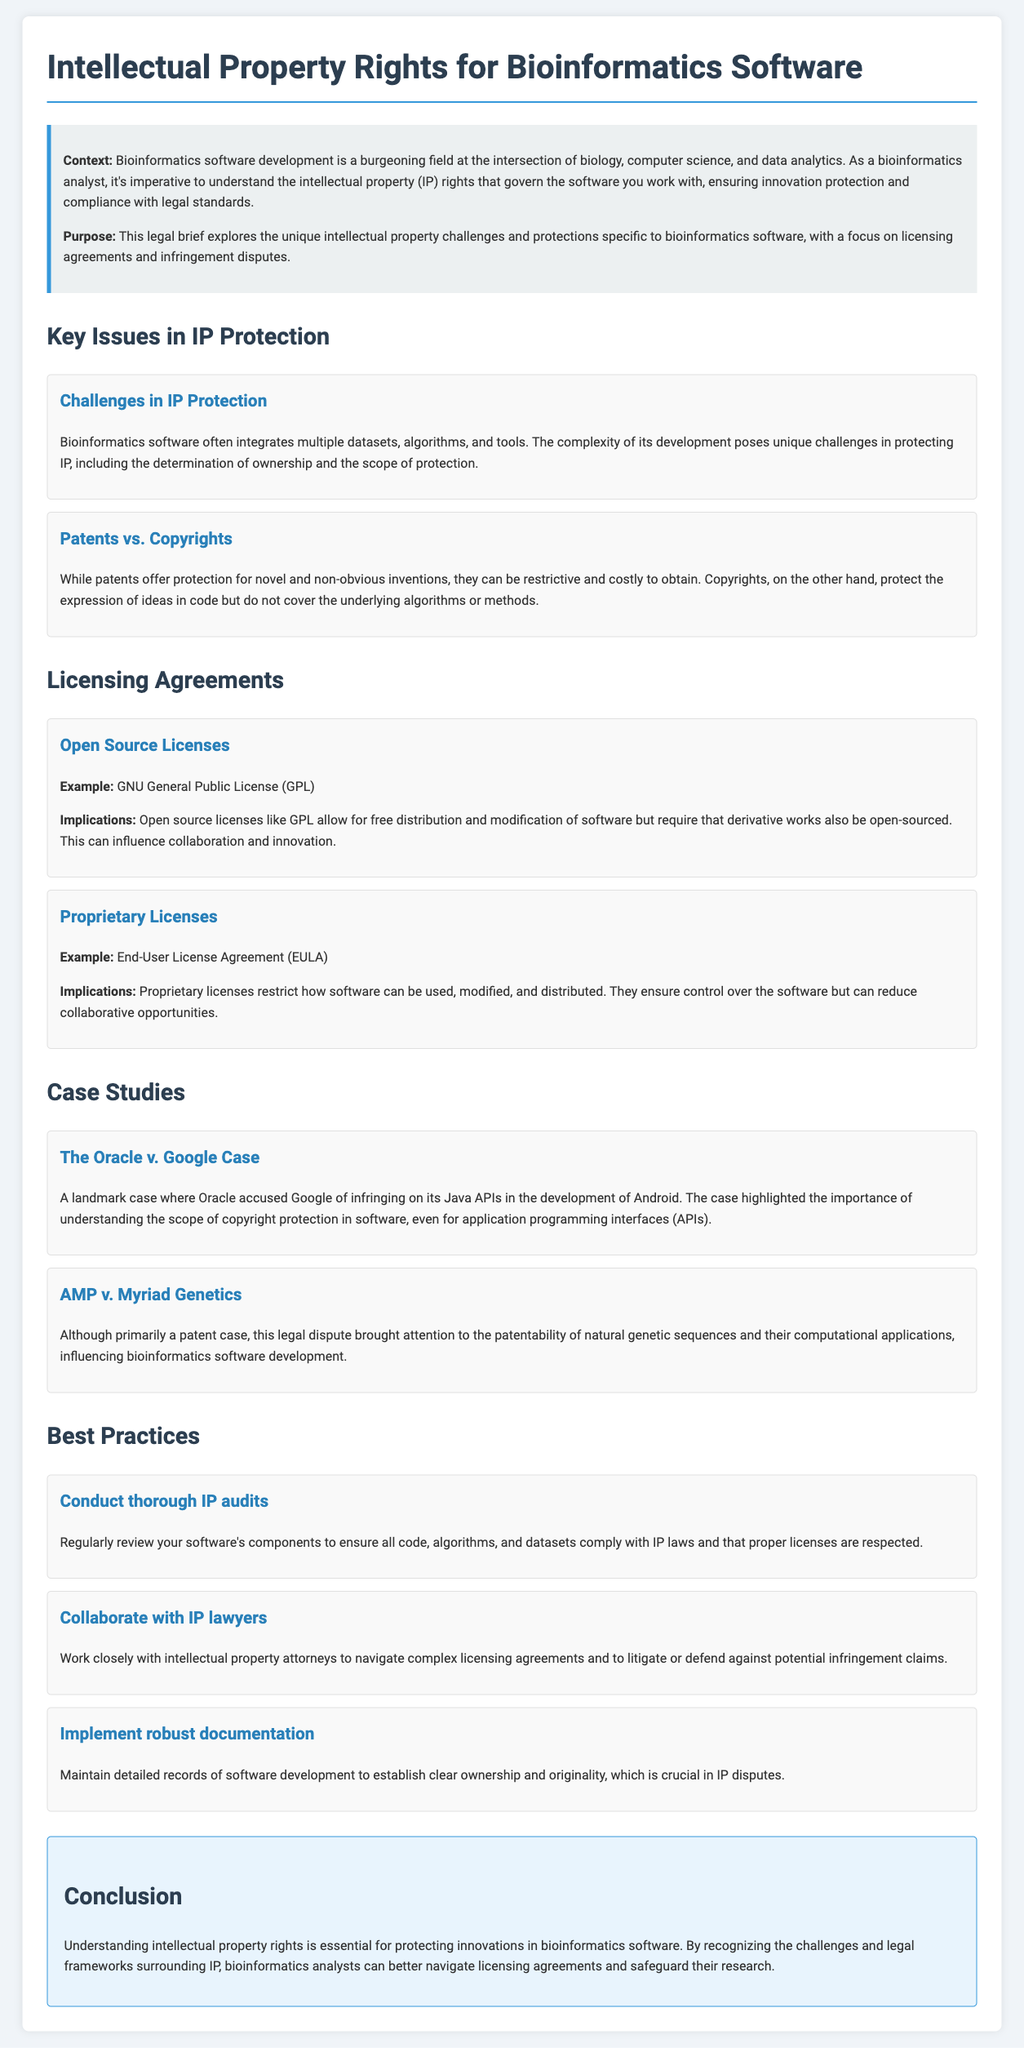What is the title of the document? The title of the document is presented prominently at the top and describes the main focus of the legal brief.
Answer: Intellectual Property Rights for Bioinformatics Software What is the primary focus of the document? The document outlines the key aspects of intellectual property rights pertinent to bioinformatics software development.
Answer: IP challenges and protections What is one challenge mentioned in IP protection? The section discusses specific issues regarding IP protection in bioinformatics software development.
Answer: Determination of ownership What is an example of an open source license? The document lists examples of licensing agreements relevant to bioinformatics software.
Answer: GNU General Public License What landmark case is discussed in the case studies? The case studies section highlights significant legal disputes relevant to software IP rights.
Answer: The Oracle v. Google Case What is one best practice recommended for bioinformatics software? The document advocates for specific strategies to effectively navigate IP issues in bioinformatics software development.
Answer: Conduct thorough IP audits Which legal aspect is NOT covered in the document? This question assesses the breadth of topics that the document includes about IP rights in software.
Answer: Trademark law What type of license does EULA represent? The section on licensing agreements specifies the nature of different licenses in the context of software.
Answer: Proprietary License What key implication does the GNU General Public License have? The document explains the consequences of this licensing type on software usage and sharing.
Answer: Requires derivative works to be open-sourced 